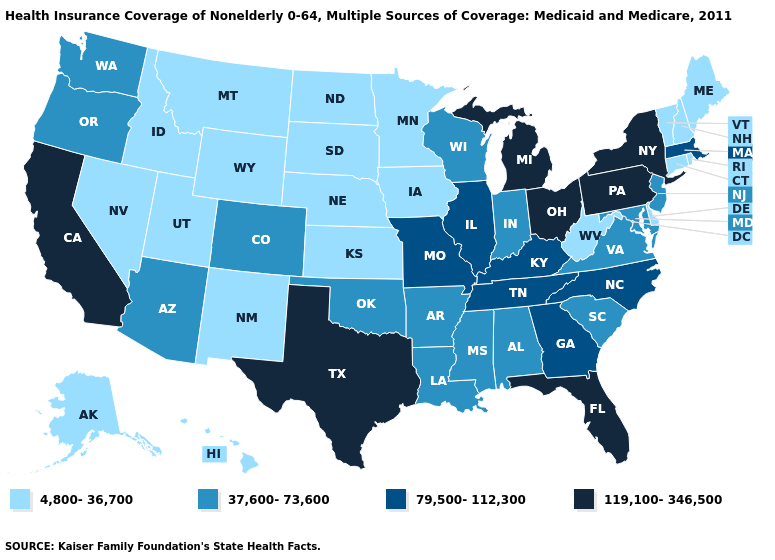What is the value of Wisconsin?
Answer briefly. 37,600-73,600. What is the lowest value in the USA?
Give a very brief answer. 4,800-36,700. Which states have the lowest value in the MidWest?
Answer briefly. Iowa, Kansas, Minnesota, Nebraska, North Dakota, South Dakota. What is the value of Nevada?
Quick response, please. 4,800-36,700. Name the states that have a value in the range 119,100-346,500?
Keep it brief. California, Florida, Michigan, New York, Ohio, Pennsylvania, Texas. Among the states that border Illinois , which have the highest value?
Keep it brief. Kentucky, Missouri. How many symbols are there in the legend?
Give a very brief answer. 4. Among the states that border Michigan , which have the lowest value?
Write a very short answer. Indiana, Wisconsin. Does Colorado have a lower value than Louisiana?
Be succinct. No. Does the map have missing data?
Short answer required. No. Does Florida have the highest value in the USA?
Quick response, please. Yes. What is the value of Arkansas?
Short answer required. 37,600-73,600. Name the states that have a value in the range 37,600-73,600?
Quick response, please. Alabama, Arizona, Arkansas, Colorado, Indiana, Louisiana, Maryland, Mississippi, New Jersey, Oklahoma, Oregon, South Carolina, Virginia, Washington, Wisconsin. Does Alaska have the lowest value in the West?
Be succinct. Yes. Name the states that have a value in the range 79,500-112,300?
Quick response, please. Georgia, Illinois, Kentucky, Massachusetts, Missouri, North Carolina, Tennessee. 